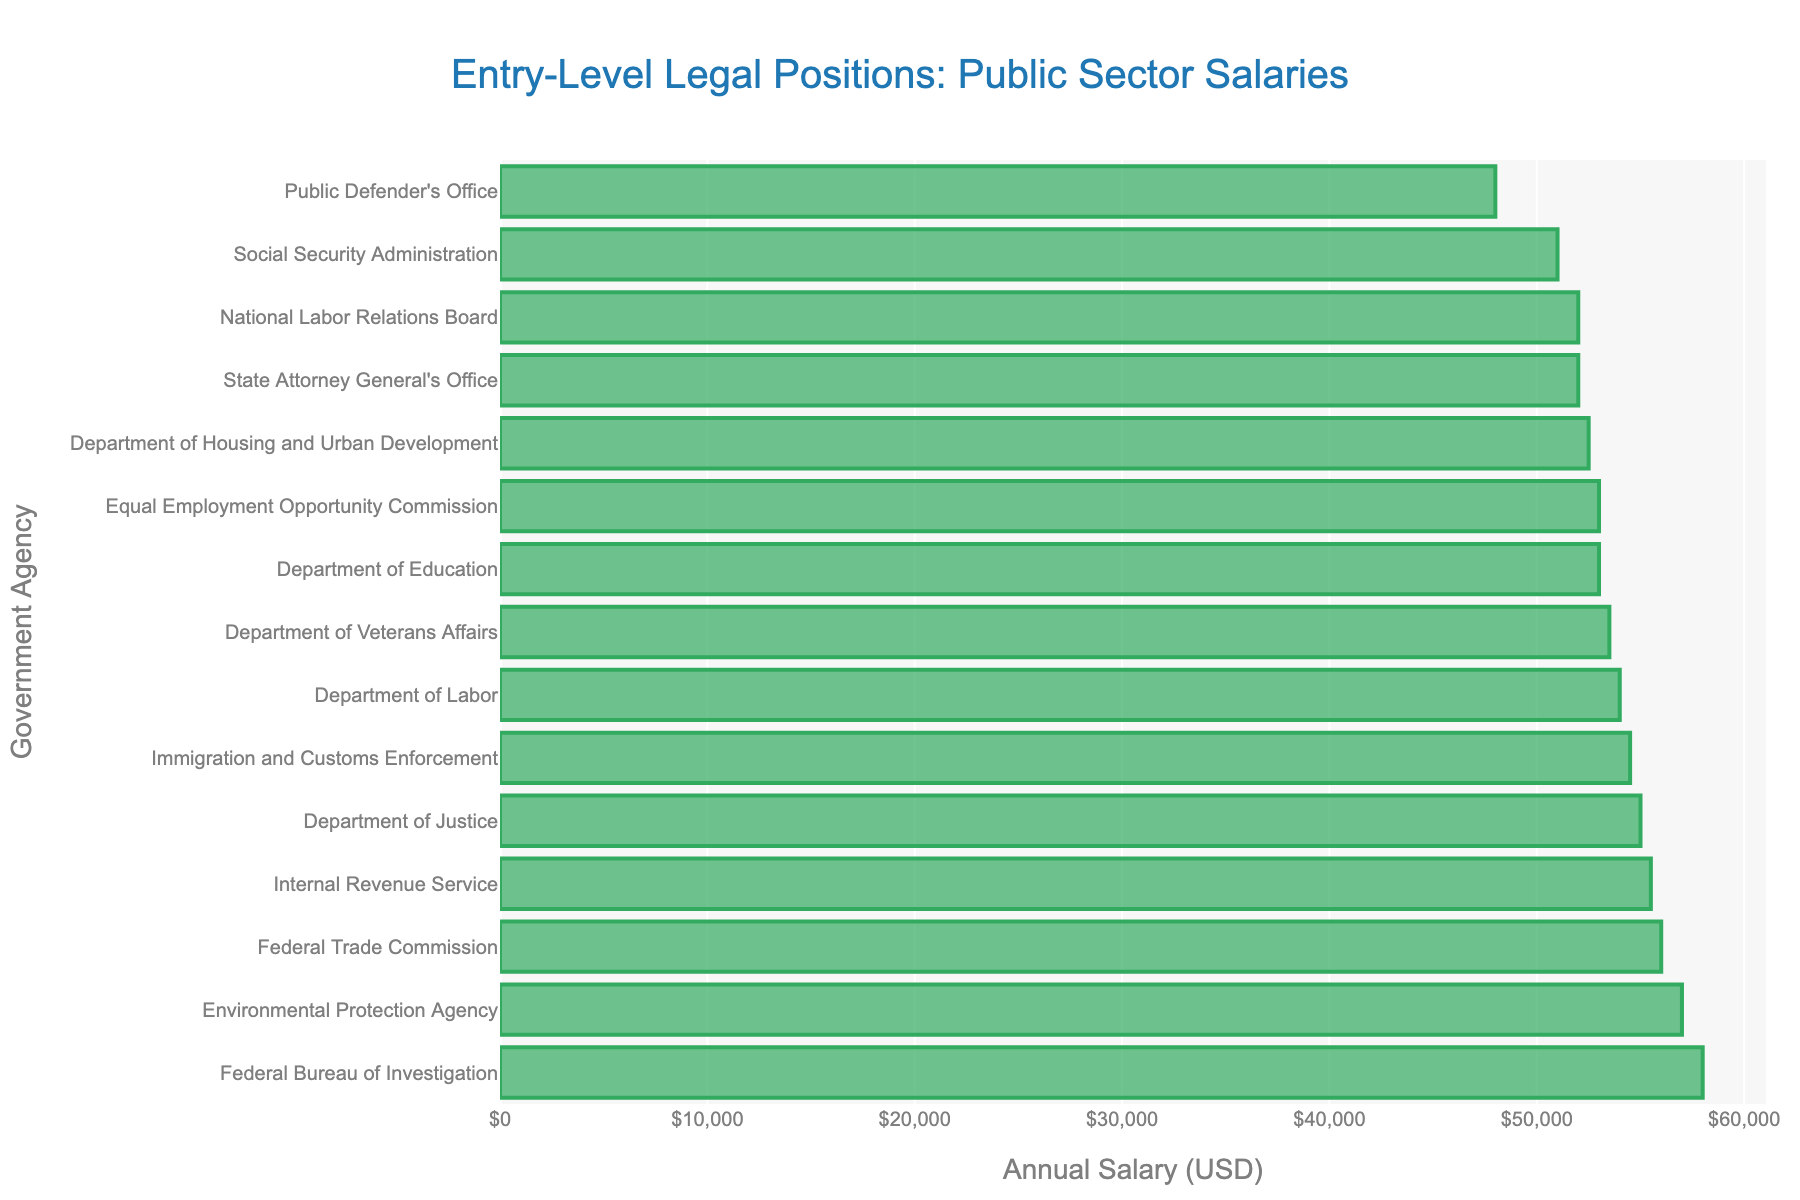Which agency offers the highest entry-level salary for legal positions? The highest bar represents the Federal Bureau of Investigation with an annual salary of $58,000.
Answer: Federal Bureau of Investigation Which agency offers the lowest entry-level salary for legal positions? The lowest bar represents the Public Defender's Office with an annual salary of $48,000.
Answer: Public Defender's Office How much more does the Environmental Protection Agency pay compared to the Public Defender's Office? The Environmental Protection Agency offers $57,000, and the Public Defender's Office offers $48,000. The difference is $57,000 - $48,000 = $9,000.
Answer: $9,000 Which agencies offer salaries higher than $55,000? Agencies with salaries higher than $55,000 are the Federal Bureau of Investigation ($58,000), Environmental Protection Agency ($57,000), Federal Trade Commission ($56,000), Internal Revenue Service ($55,500), and Department of Justice ($55,000), all higher than $55,000.
Answer: Federal Bureau of Investigation, Environmental Protection Agency, Federal Trade Commission, Internal Revenue Service, Department of Justice What's the average entry-level salary of the Internal Revenue Service, Department of Labor, and Department of Education? Sum the salaries: $55,500 (IRS) + $54,000 (Dept. of Labor) + $53,000 (Dept. of Education) = $162,500. Average: $162,500 / 3 = $54,167.
Answer: $54,167 Which agency is positioned between the Department of Housing and Urban Development and Equal Employment Opportunity Commission based on salary? In the sorted list, the Department of Veterans Affairs with a salary of $53,500 is between the Department of HUD ($52,500) and Equal Employment Opportunity Commission ($53,000).
Answer: Department of Veterans Affairs Compare the salaries of the Department of Justice and Immigration and Customs Enforcement. Which is higher and by how much? The Department of Justice pays $55,000, and Immigration and Customs Enforcement pays $54,500. The Department of Justice's salary is higher by $55,000 - $54,500 = $500.
Answer: $500 What is the median salary of the listed agencies? There are 15 agencies. When sorted, the 8th salary is the median. Middle value (position 8/15) = $53,500 (Department of Veterans Affairs).
Answer: $53,500 How do the salaries of the Department of Labor and Social Security Administration compare? The Department of Labor offers $54,000 and the Social Security Administration offers $51,000. The Department of Labor's salary is higher by $54,000 - $51,000 = $3,000.
Answer: $3,000 What's the total sum of salaries for the Federal Bureau of Investigation and National Labor Relations Board? The FBI offers $58,000 and NLRB offers $52,000. Sum: $58,000 + $52,000 = $110,000.
Answer: $110,000 